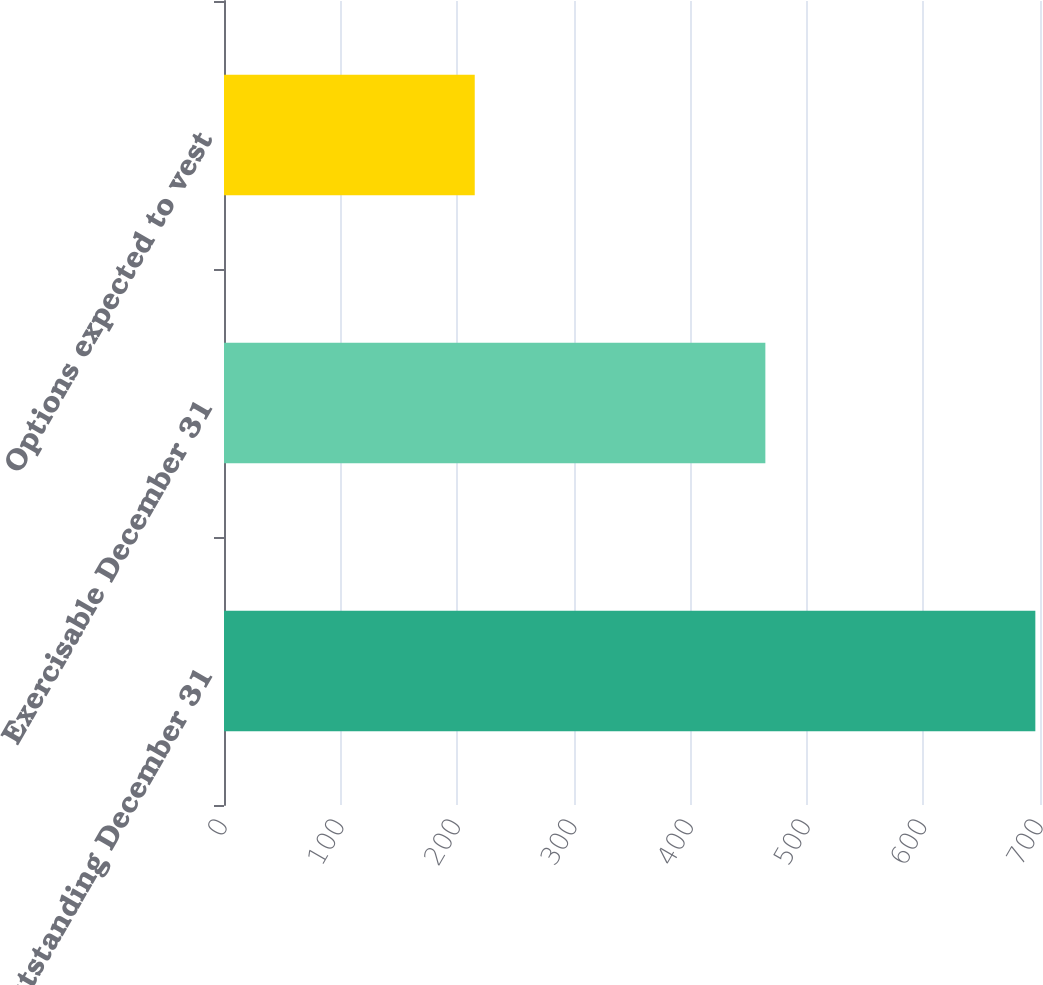Convert chart to OTSL. <chart><loc_0><loc_0><loc_500><loc_500><bar_chart><fcel>Outstanding December 31<fcel>Exercisable December 31<fcel>Options expected to vest<nl><fcel>696<fcel>464.4<fcel>215.1<nl></chart> 